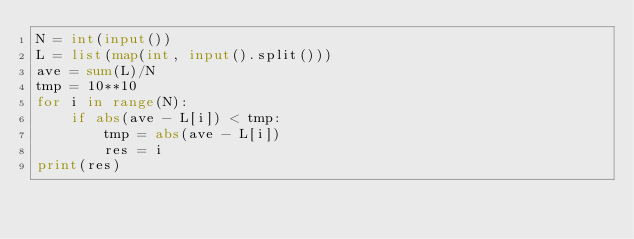Convert code to text. <code><loc_0><loc_0><loc_500><loc_500><_Python_>N = int(input())
L = list(map(int, input().split()))
ave = sum(L)/N
tmp = 10**10
for i in range(N):
    if abs(ave - L[i]) < tmp:
        tmp = abs(ave - L[i])
        res = i
print(res)</code> 